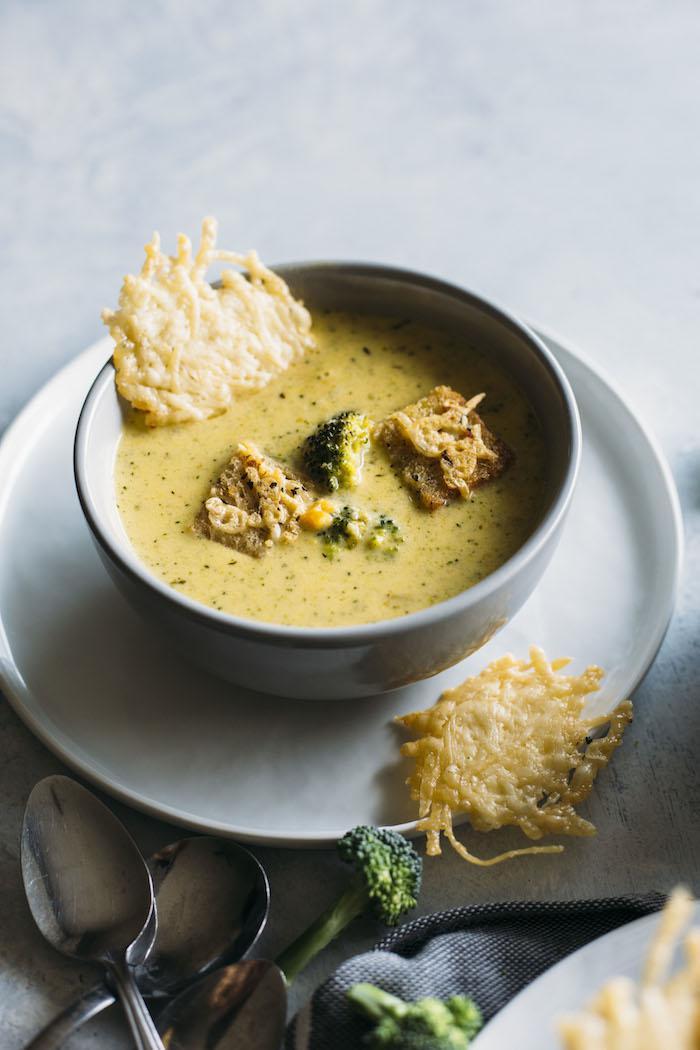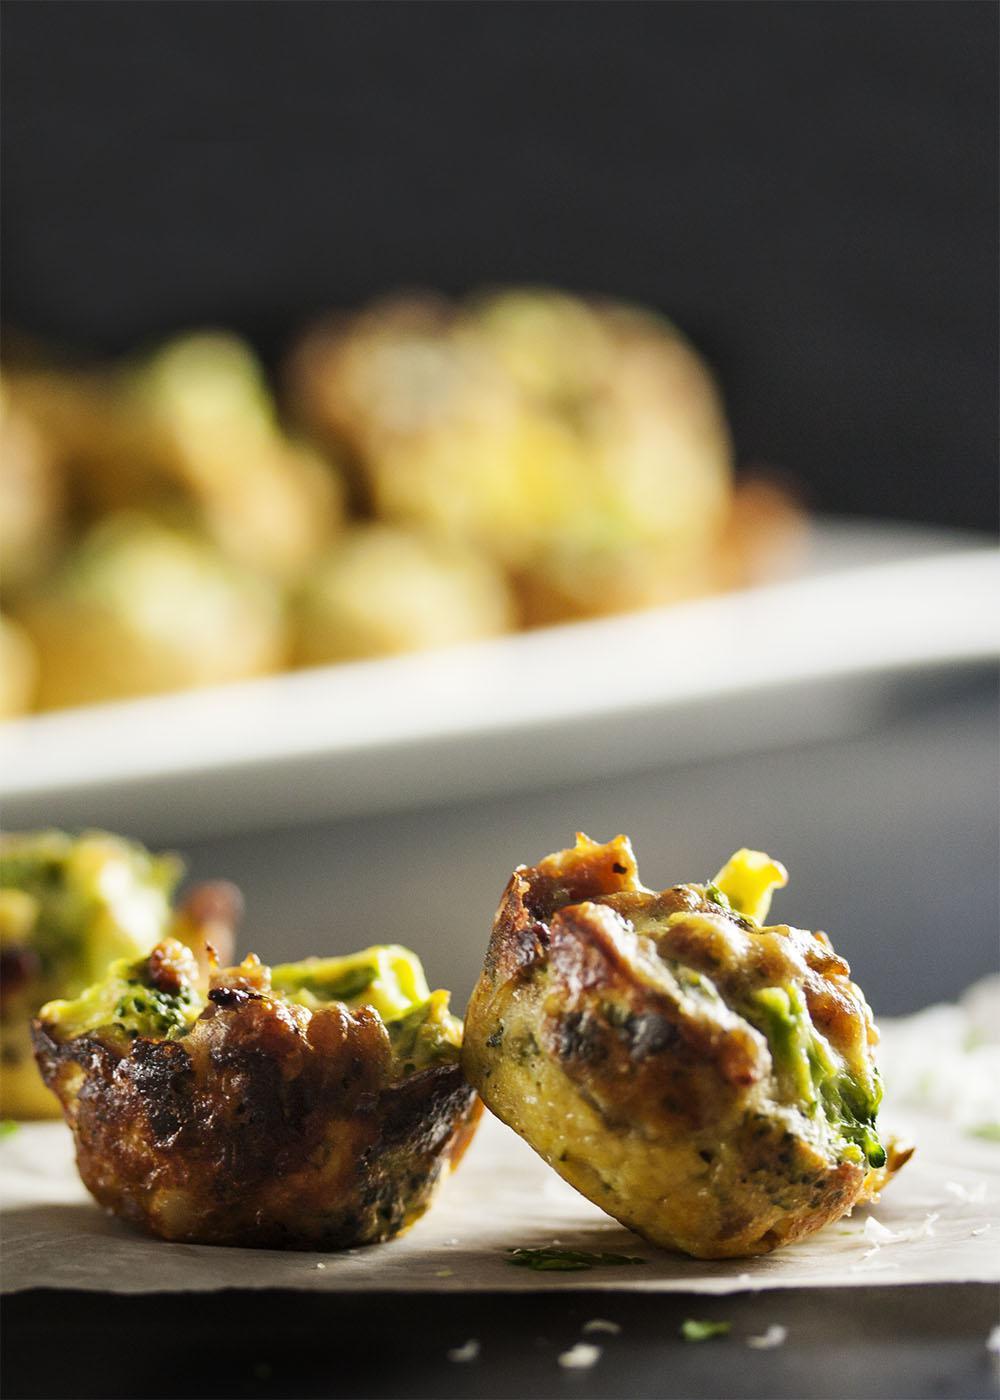The first image is the image on the left, the second image is the image on the right. Given the left and right images, does the statement "An image shows a utensil inserted in a bowl of creamy soup." hold true? Answer yes or no. No. 